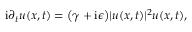Convert formula to latex. <formula><loc_0><loc_0><loc_500><loc_500>i \partial _ { t } u ( x , t ) = \left ( \gamma + i \epsilon \right ) | u ( x , t ) | ^ { 2 } u ( x , t ) ,</formula> 